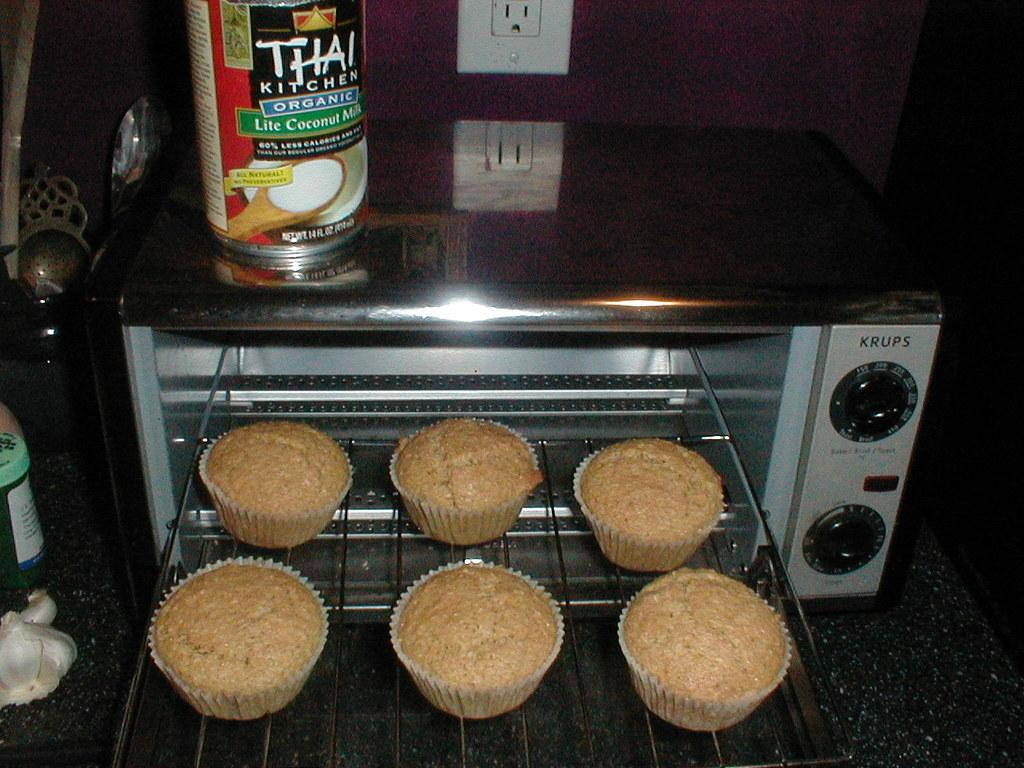<image>
Provide a brief description of the given image. Some muffins and a tin of something which has the word Thai Kitchen on it. 